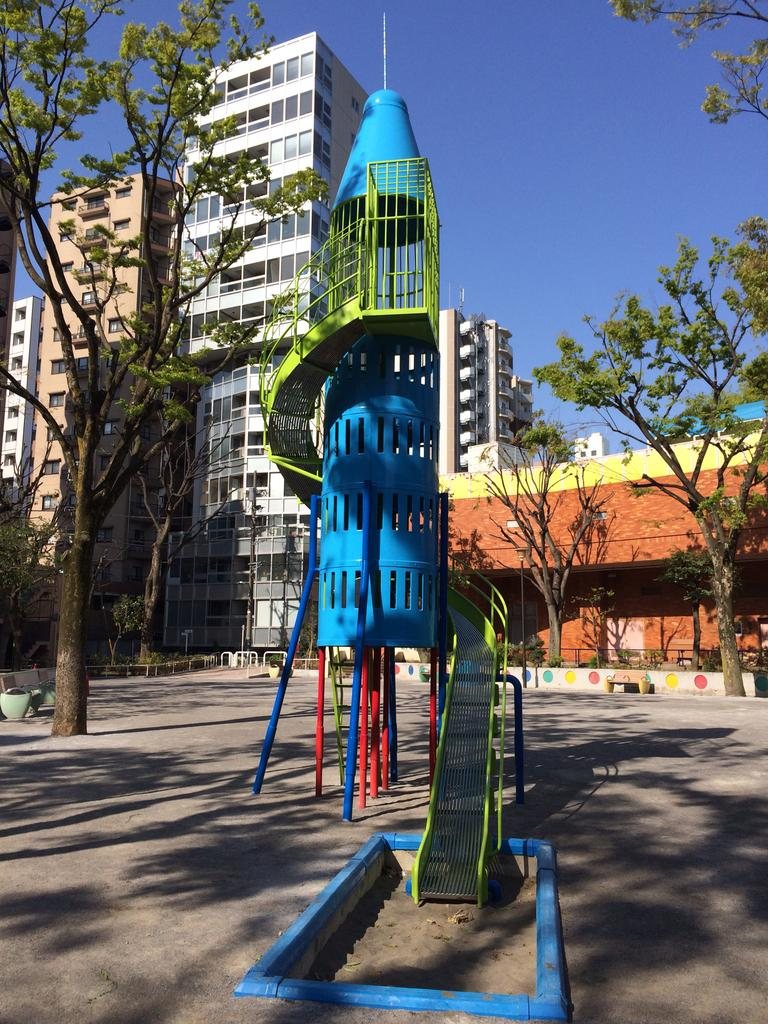What type of location is depicted in the image? The image is an outside view. What is the main feature in the middle of the image? There is a slide in the middle of the image. What can be seen in the background of the image? There are many trees and buildings in the background of the image. What is the color of the sky in the image? The sky is visible at the top of the image and has a blue color. What type of apple is being regretted in the image? There is no apple or any indication of regret present in the image. 